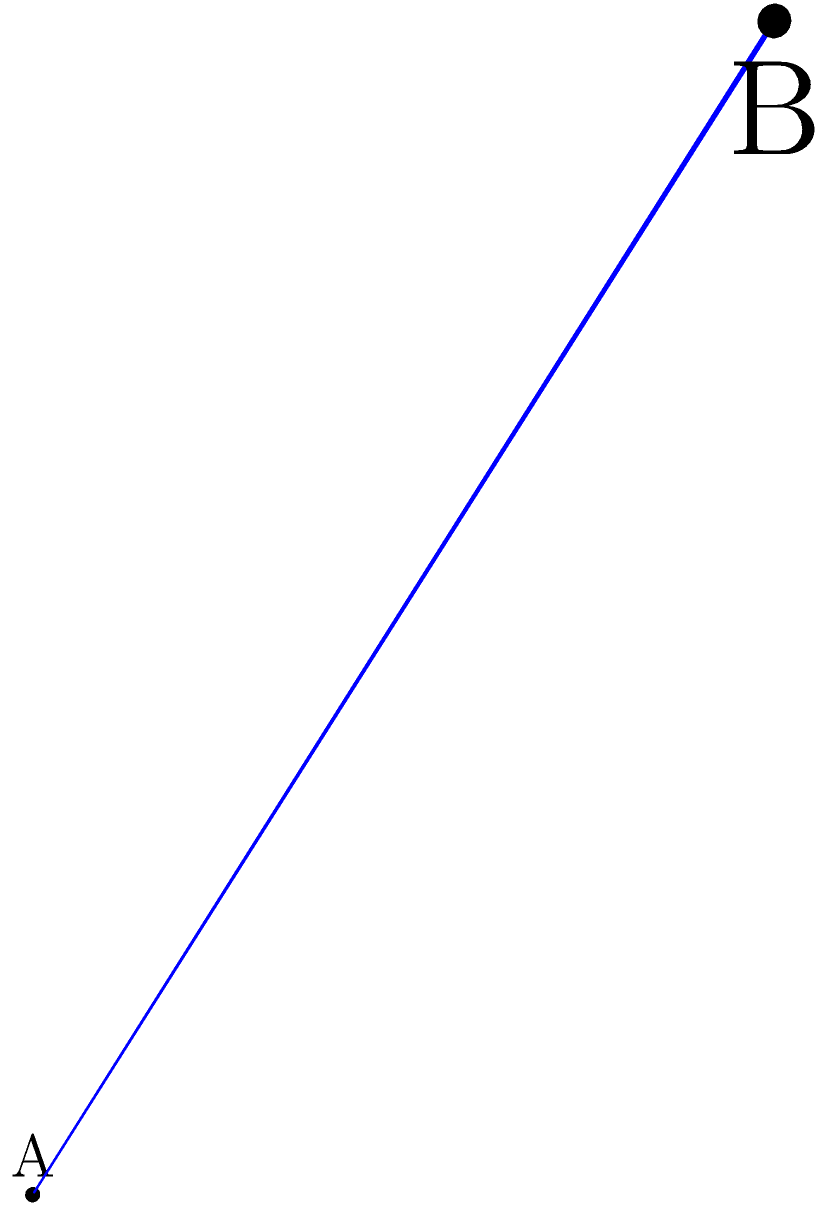Given two points A(0,0,0) and B(3,4,5) in a 3D coordinate system, calculate the shortest distance between these points. To find the shortest distance between two points in a 3D coordinate system, we can use the distance formula derived from the Pythagorean theorem in three dimensions. Here's how we can solve this step-by-step:

1. The distance formula in 3D is:
   $$d = \sqrt{(x_2-x_1)^2 + (y_2-y_1)^2 + (z_2-z_1)^2}$$

2. We have:
   Point A: $(x_1, y_1, z_1) = (0, 0, 0)$
   Point B: $(x_2, y_2, z_2) = (3, 4, 5)$

3. Let's substitute these values into the formula:
   $$d = \sqrt{(3-0)^2 + (4-0)^2 + (5-0)^2}$$

4. Simplify:
   $$d = \sqrt{3^2 + 4^2 + 5^2}$$

5. Calculate the squares:
   $$d = \sqrt{9 + 16 + 25}$$

6. Sum up under the square root:
   $$d = \sqrt{50}$$

7. Simplify the square root:
   $$d = 5\sqrt{2}$$

Therefore, the shortest distance between points A and B is $5\sqrt{2}$ units.
Answer: $5\sqrt{2}$ units 